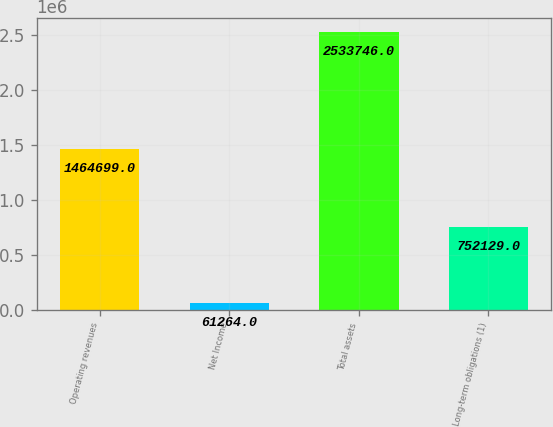Convert chart to OTSL. <chart><loc_0><loc_0><loc_500><loc_500><bar_chart><fcel>Operating revenues<fcel>Net Income<fcel>Total assets<fcel>Long-term obligations (1)<nl><fcel>1.4647e+06<fcel>61264<fcel>2.53375e+06<fcel>752129<nl></chart> 